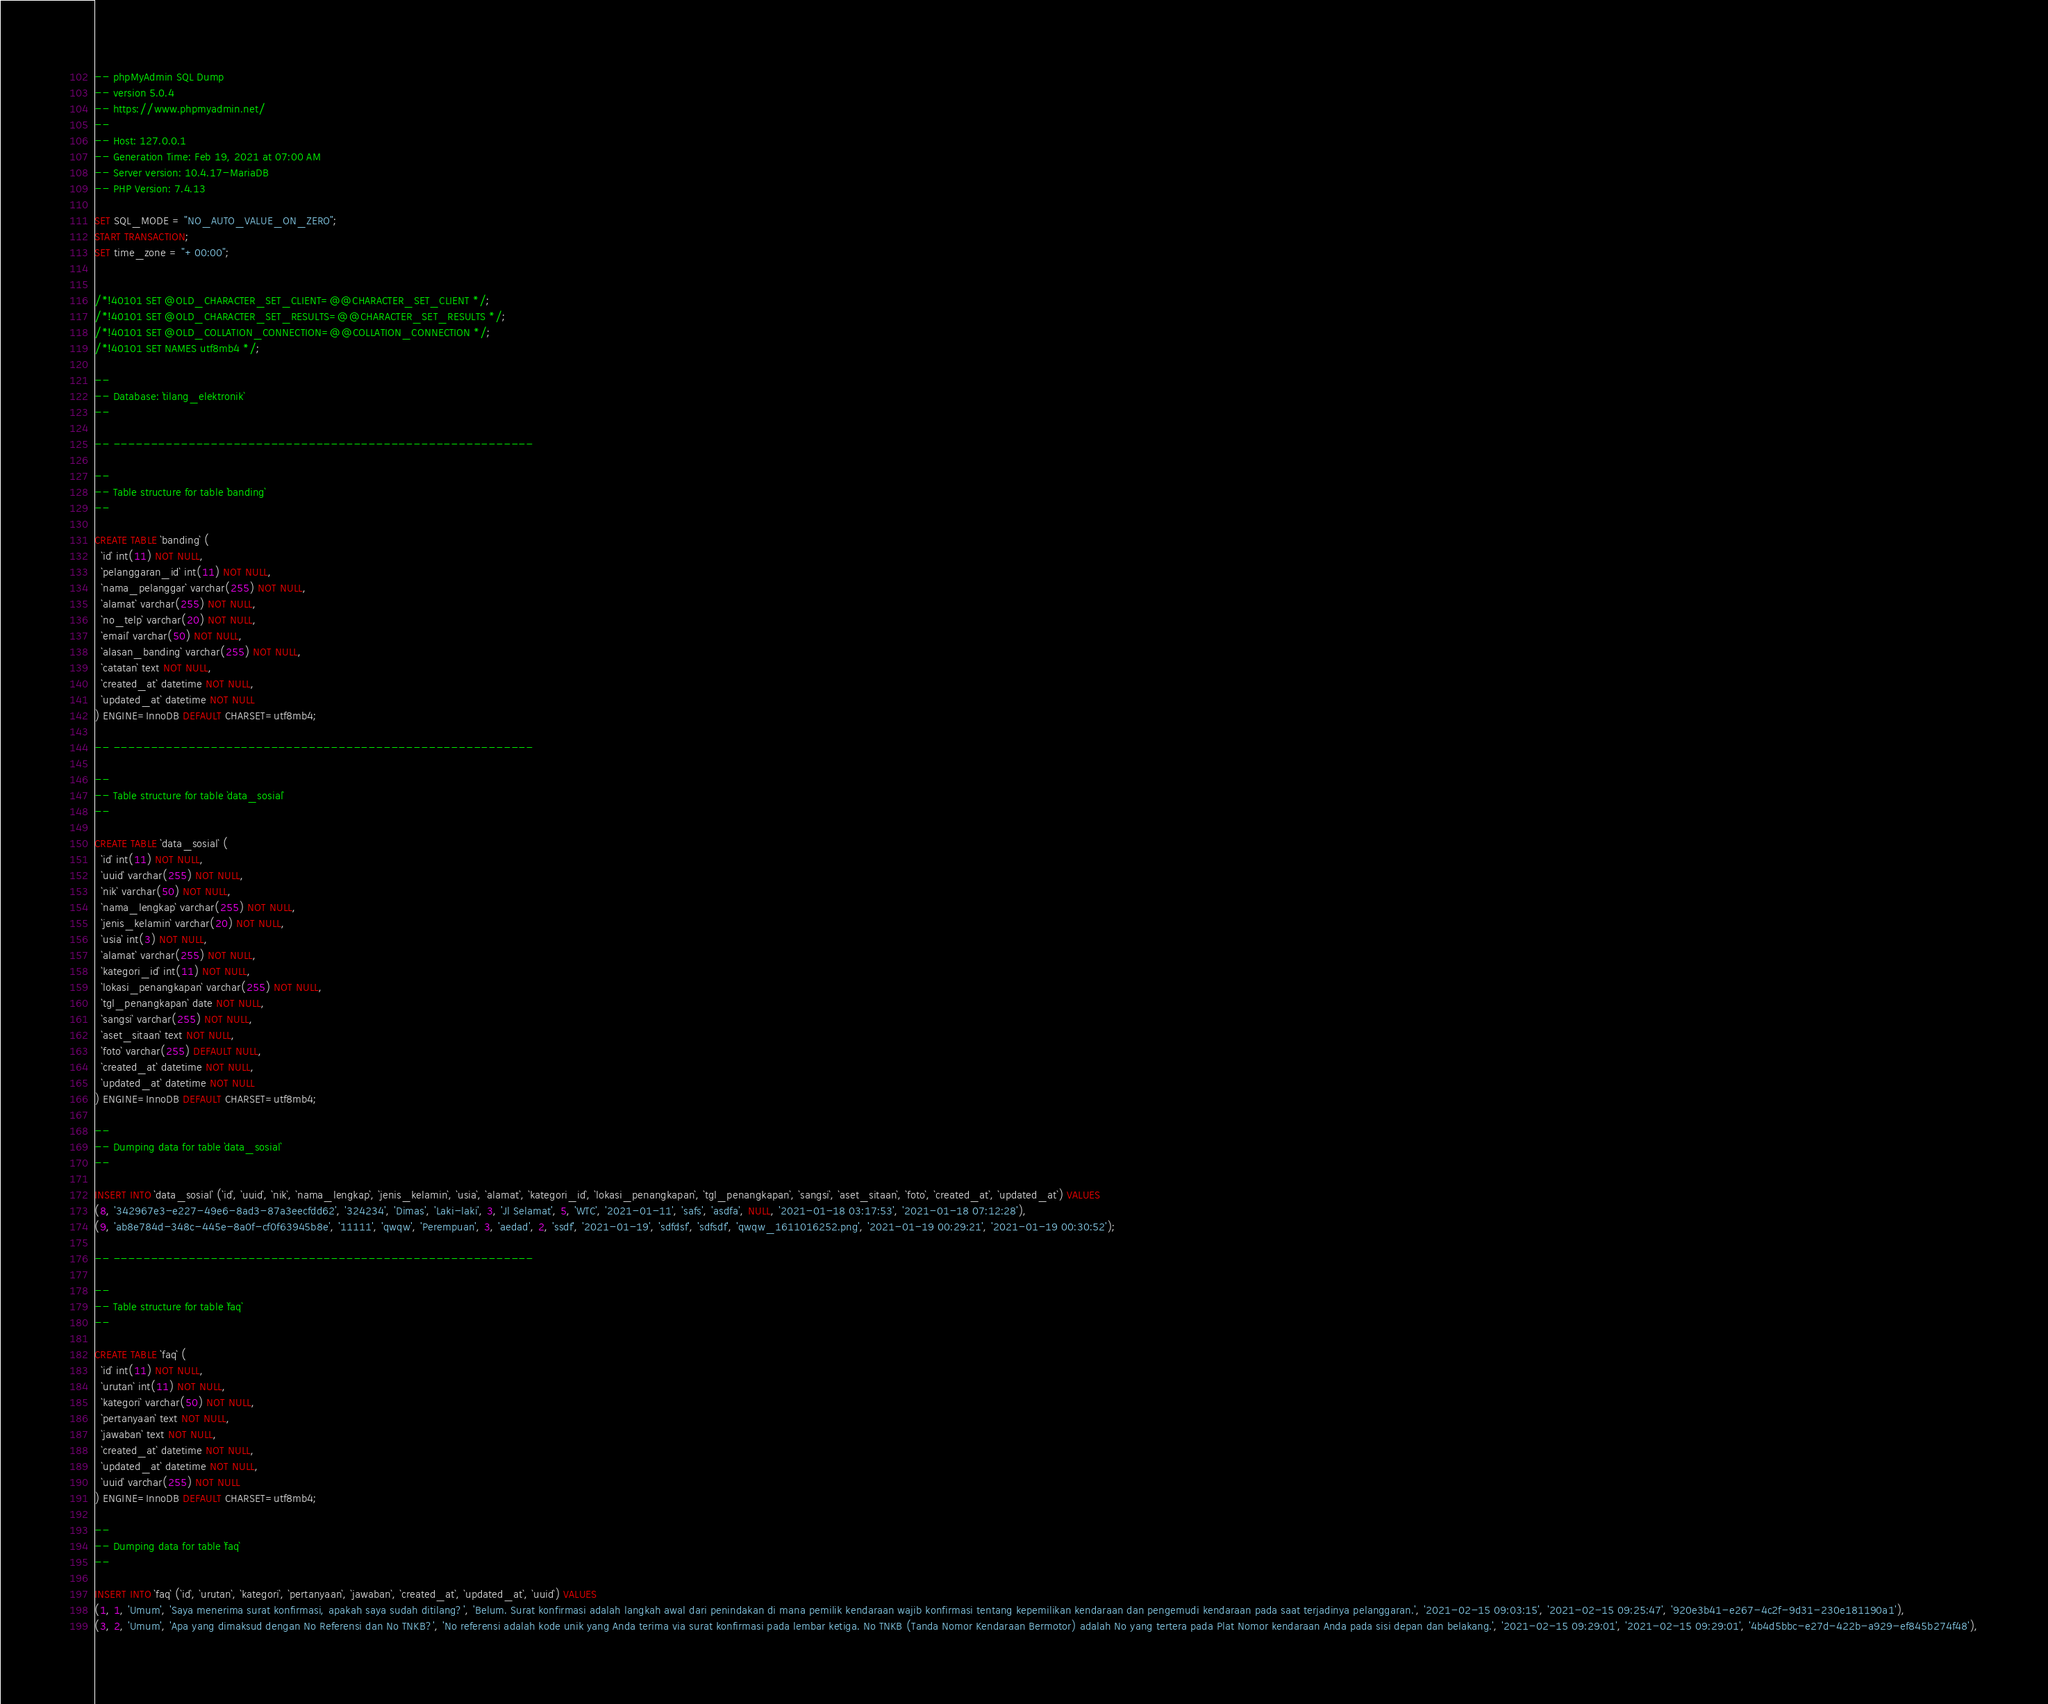Convert code to text. <code><loc_0><loc_0><loc_500><loc_500><_SQL_>-- phpMyAdmin SQL Dump
-- version 5.0.4
-- https://www.phpmyadmin.net/
--
-- Host: 127.0.0.1
-- Generation Time: Feb 19, 2021 at 07:00 AM
-- Server version: 10.4.17-MariaDB
-- PHP Version: 7.4.13

SET SQL_MODE = "NO_AUTO_VALUE_ON_ZERO";
START TRANSACTION;
SET time_zone = "+00:00";


/*!40101 SET @OLD_CHARACTER_SET_CLIENT=@@CHARACTER_SET_CLIENT */;
/*!40101 SET @OLD_CHARACTER_SET_RESULTS=@@CHARACTER_SET_RESULTS */;
/*!40101 SET @OLD_COLLATION_CONNECTION=@@COLLATION_CONNECTION */;
/*!40101 SET NAMES utf8mb4 */;

--
-- Database: `tilang_elektronik`
--

-- --------------------------------------------------------

--
-- Table structure for table `banding`
--

CREATE TABLE `banding` (
  `id` int(11) NOT NULL,
  `pelanggaran_id` int(11) NOT NULL,
  `nama_pelanggar` varchar(255) NOT NULL,
  `alamat` varchar(255) NOT NULL,
  `no_telp` varchar(20) NOT NULL,
  `email` varchar(50) NOT NULL,
  `alasan_banding` varchar(255) NOT NULL,
  `catatan` text NOT NULL,
  `created_at` datetime NOT NULL,
  `updated_at` datetime NOT NULL
) ENGINE=InnoDB DEFAULT CHARSET=utf8mb4;

-- --------------------------------------------------------

--
-- Table structure for table `data_sosial`
--

CREATE TABLE `data_sosial` (
  `id` int(11) NOT NULL,
  `uuid` varchar(255) NOT NULL,
  `nik` varchar(50) NOT NULL,
  `nama_lengkap` varchar(255) NOT NULL,
  `jenis_kelamin` varchar(20) NOT NULL,
  `usia` int(3) NOT NULL,
  `alamat` varchar(255) NOT NULL,
  `kategori_id` int(11) NOT NULL,
  `lokasi_penangkapan` varchar(255) NOT NULL,
  `tgl_penangkapan` date NOT NULL,
  `sangsi` varchar(255) NOT NULL,
  `aset_sitaan` text NOT NULL,
  `foto` varchar(255) DEFAULT NULL,
  `created_at` datetime NOT NULL,
  `updated_at` datetime NOT NULL
) ENGINE=InnoDB DEFAULT CHARSET=utf8mb4;

--
-- Dumping data for table `data_sosial`
--

INSERT INTO `data_sosial` (`id`, `uuid`, `nik`, `nama_lengkap`, `jenis_kelamin`, `usia`, `alamat`, `kategori_id`, `lokasi_penangkapan`, `tgl_penangkapan`, `sangsi`, `aset_sitaan`, `foto`, `created_at`, `updated_at`) VALUES
(8, '342967e3-e227-49e6-8ad3-87a3eecfdd62', '324234', 'Dimas', 'Laki-laki', 3, 'Jl Selamat', 5, 'WTC', '2021-01-11', 'safs', 'asdfa', NULL, '2021-01-18 03:17:53', '2021-01-18 07:12:28'),
(9, 'ab8e784d-348c-445e-8a0f-cf0f63945b8e', '11111', 'qwqw', 'Perempuan', 3, 'aedad', 2, 'ssdf', '2021-01-19', 'sdfdsf', 'sdfsdf', 'qwqw_1611016252.png', '2021-01-19 00:29:21', '2021-01-19 00:30:52');

-- --------------------------------------------------------

--
-- Table structure for table `faq`
--

CREATE TABLE `faq` (
  `id` int(11) NOT NULL,
  `urutan` int(11) NOT NULL,
  `kategori` varchar(50) NOT NULL,
  `pertanyaan` text NOT NULL,
  `jawaban` text NOT NULL,
  `created_at` datetime NOT NULL,
  `updated_at` datetime NOT NULL,
  `uuid` varchar(255) NOT NULL
) ENGINE=InnoDB DEFAULT CHARSET=utf8mb4;

--
-- Dumping data for table `faq`
--

INSERT INTO `faq` (`id`, `urutan`, `kategori`, `pertanyaan`, `jawaban`, `created_at`, `updated_at`, `uuid`) VALUES
(1, 1, 'Umum', 'Saya menerima surat konfirmasi, apakah saya sudah ditilang?', 'Belum. Surat konfirmasi adalah langkah awal dari penindakan di mana pemilik kendaraan wajib konfirmasi tentang kepemilikan kendaraan dan pengemudi kendaraan pada saat terjadinya pelanggaran.', '2021-02-15 09:03:15', '2021-02-15 09:25:47', '920e3b41-e267-4c2f-9d31-230e181190a1'),
(3, 2, 'Umum', 'Apa yang dimaksud dengan No Referensi dan No TNKB?', 'No referensi adalah kode unik yang Anda terima via surat konfirmasi pada lembar ketiga. No TNKB (Tanda Nomor Kendaraan Bermotor) adalah No yang tertera pada Plat Nomor kendaraan Anda pada sisi depan dan belakang.', '2021-02-15 09:29:01', '2021-02-15 09:29:01', '4b4d5bbc-e27d-422b-a929-ef845b274f48'),</code> 